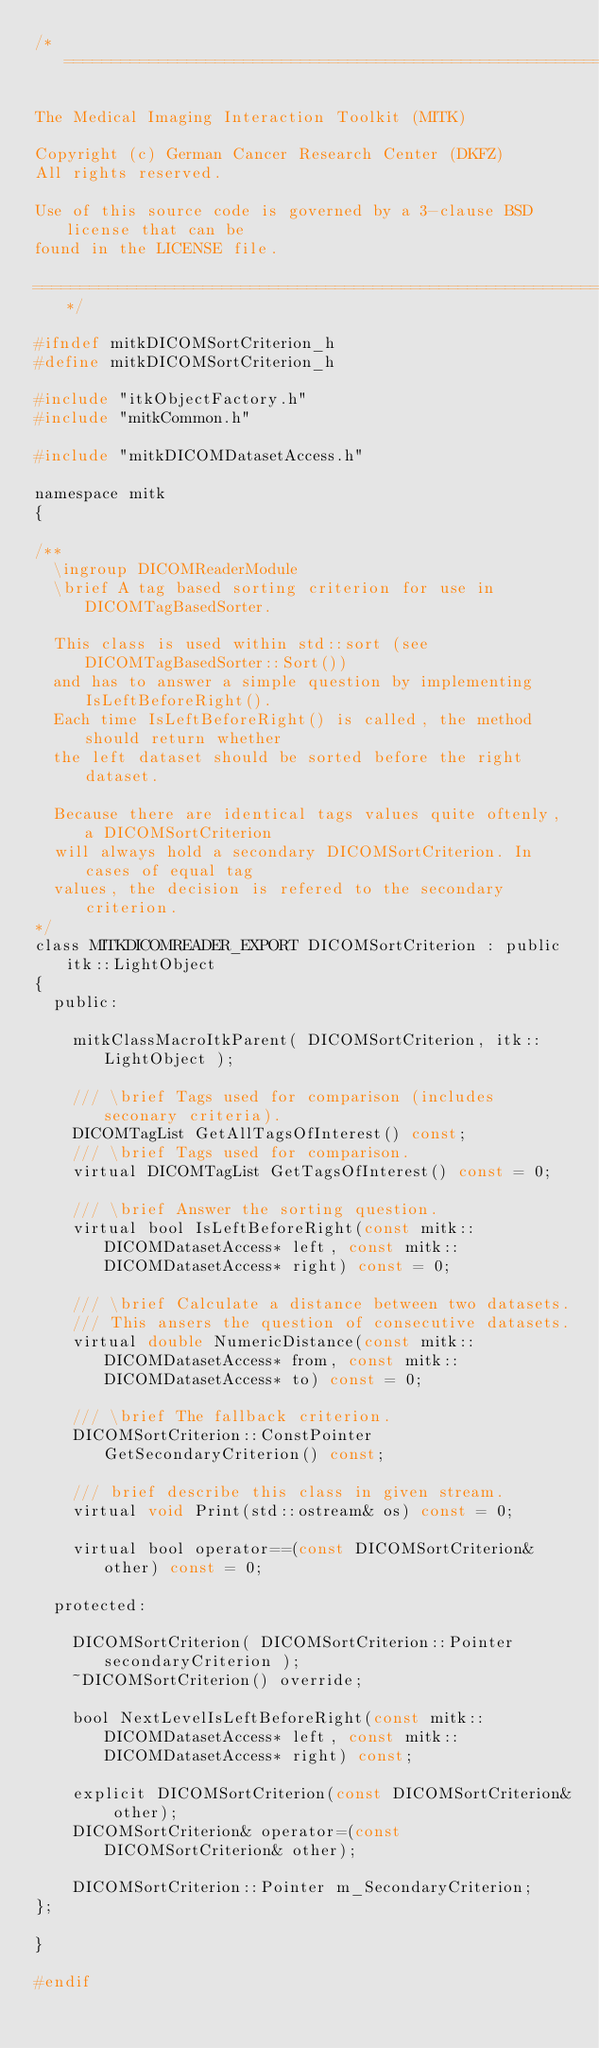<code> <loc_0><loc_0><loc_500><loc_500><_C_>/*============================================================================

The Medical Imaging Interaction Toolkit (MITK)

Copyright (c) German Cancer Research Center (DKFZ)
All rights reserved.

Use of this source code is governed by a 3-clause BSD license that can be
found in the LICENSE file.

============================================================================*/

#ifndef mitkDICOMSortCriterion_h
#define mitkDICOMSortCriterion_h

#include "itkObjectFactory.h"
#include "mitkCommon.h"

#include "mitkDICOMDatasetAccess.h"

namespace mitk
{

/**
  \ingroup DICOMReaderModule
  \brief A tag based sorting criterion for use in DICOMTagBasedSorter.

  This class is used within std::sort (see DICOMTagBasedSorter::Sort())
  and has to answer a simple question by implementing IsLeftBeforeRight().
  Each time IsLeftBeforeRight() is called, the method should return whether
  the left dataset should be sorted before the right dataset.

  Because there are identical tags values quite oftenly, a DICOMSortCriterion
  will always hold a secondary DICOMSortCriterion. In cases of equal tag
  values, the decision is refered to the secondary criterion.
*/
class MITKDICOMREADER_EXPORT DICOMSortCriterion : public itk::LightObject
{
  public:

    mitkClassMacroItkParent( DICOMSortCriterion, itk::LightObject );

    /// \brief Tags used for comparison (includes seconary criteria).
    DICOMTagList GetAllTagsOfInterest() const;
    /// \brief Tags used for comparison.
    virtual DICOMTagList GetTagsOfInterest() const = 0;

    /// \brief Answer the sorting question.
    virtual bool IsLeftBeforeRight(const mitk::DICOMDatasetAccess* left, const mitk::DICOMDatasetAccess* right) const = 0;

    /// \brief Calculate a distance between two datasets.
    /// This ansers the question of consecutive datasets.
    virtual double NumericDistance(const mitk::DICOMDatasetAccess* from, const mitk::DICOMDatasetAccess* to) const = 0;

    /// \brief The fallback criterion.
    DICOMSortCriterion::ConstPointer GetSecondaryCriterion() const;

    /// brief describe this class in given stream.
    virtual void Print(std::ostream& os) const = 0;

    virtual bool operator==(const DICOMSortCriterion& other) const = 0;

  protected:

    DICOMSortCriterion( DICOMSortCriterion::Pointer secondaryCriterion );
    ~DICOMSortCriterion() override;

    bool NextLevelIsLeftBeforeRight(const mitk::DICOMDatasetAccess* left, const mitk::DICOMDatasetAccess* right) const;

    explicit DICOMSortCriterion(const DICOMSortCriterion& other);
    DICOMSortCriterion& operator=(const DICOMSortCriterion& other);

    DICOMSortCriterion::Pointer m_SecondaryCriterion;
};

}

#endif
</code> 